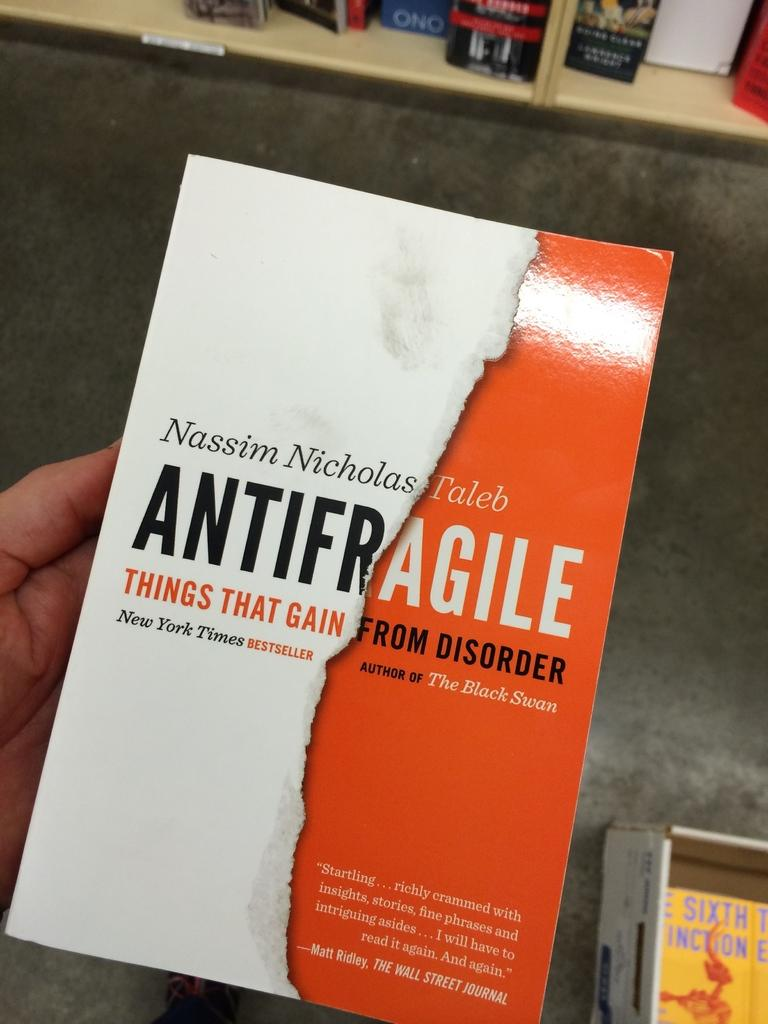<image>
Create a compact narrative representing the image presented. A person is holding a book by Nassim Nicholas Taleb called "Antifragile". 